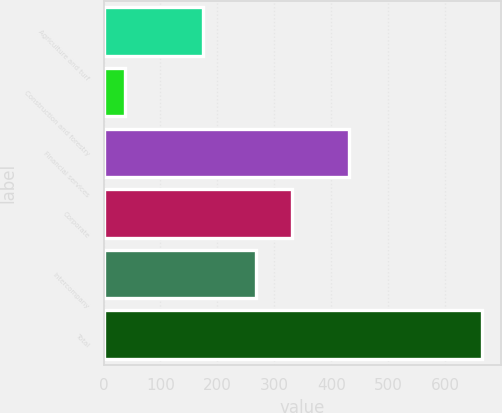Convert chart. <chart><loc_0><loc_0><loc_500><loc_500><bar_chart><fcel>Agriculture and turf<fcel>Construction and forestry<fcel>Financial services<fcel>Corporate<fcel>Intercompany<fcel>Total<nl><fcel>175<fcel>37<fcel>431<fcel>330.7<fcel>268<fcel>664<nl></chart> 